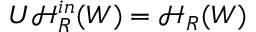<formula> <loc_0><loc_0><loc_500><loc_500>U \mathcal { H } _ { R } ^ { i n } ( W ) = \mathcal { H } _ { R } ( W )</formula> 